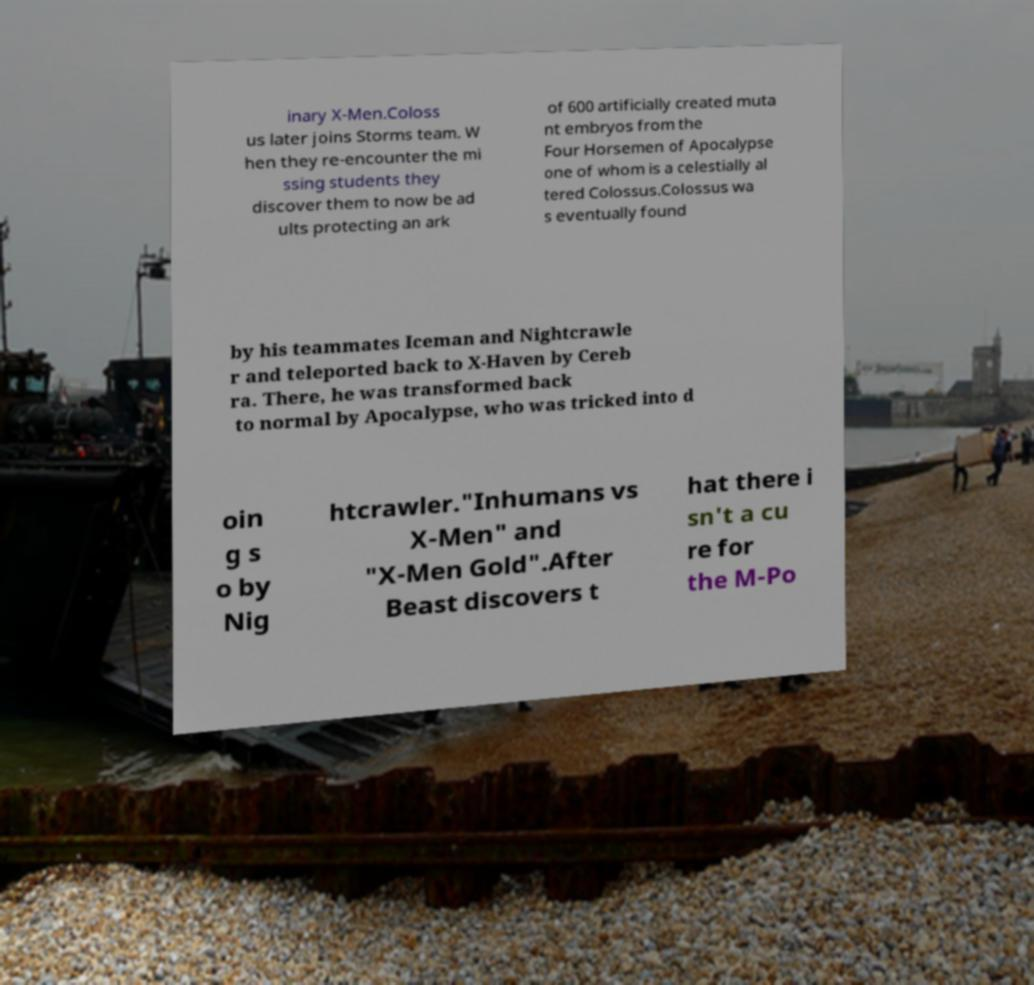For documentation purposes, I need the text within this image transcribed. Could you provide that? inary X-Men.Coloss us later joins Storms team. W hen they re-encounter the mi ssing students they discover them to now be ad ults protecting an ark of 600 artificially created muta nt embryos from the Four Horsemen of Apocalypse one of whom is a celestially al tered Colossus.Colossus wa s eventually found by his teammates Iceman and Nightcrawle r and teleported back to X-Haven by Cereb ra. There, he was transformed back to normal by Apocalypse, who was tricked into d oin g s o by Nig htcrawler."Inhumans vs X-Men" and "X-Men Gold".After Beast discovers t hat there i sn't a cu re for the M-Po 